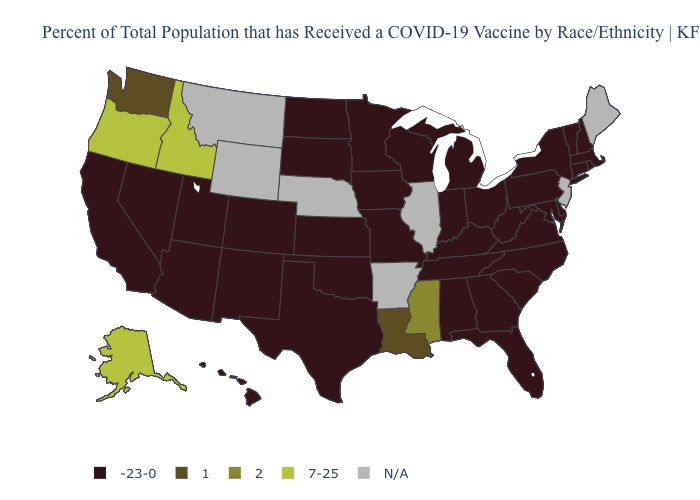Name the states that have a value in the range 2?
Quick response, please. Mississippi. What is the value of Wyoming?
Concise answer only. N/A. Name the states that have a value in the range 2?
Give a very brief answer. Mississippi. Name the states that have a value in the range N/A?
Be succinct. Arkansas, Illinois, Maine, Montana, Nebraska, New Jersey, Wyoming. Name the states that have a value in the range 7-25?
Concise answer only. Alaska, Idaho, Oregon. Name the states that have a value in the range 1?
Short answer required. Louisiana, Washington. Is the legend a continuous bar?
Answer briefly. No. Name the states that have a value in the range 2?
Give a very brief answer. Mississippi. What is the highest value in states that border California?
Answer briefly. 7-25. What is the value of Indiana?
Answer briefly. -23-0. Which states have the lowest value in the MidWest?
Be succinct. Indiana, Iowa, Kansas, Michigan, Minnesota, Missouri, North Dakota, Ohio, South Dakota, Wisconsin. 